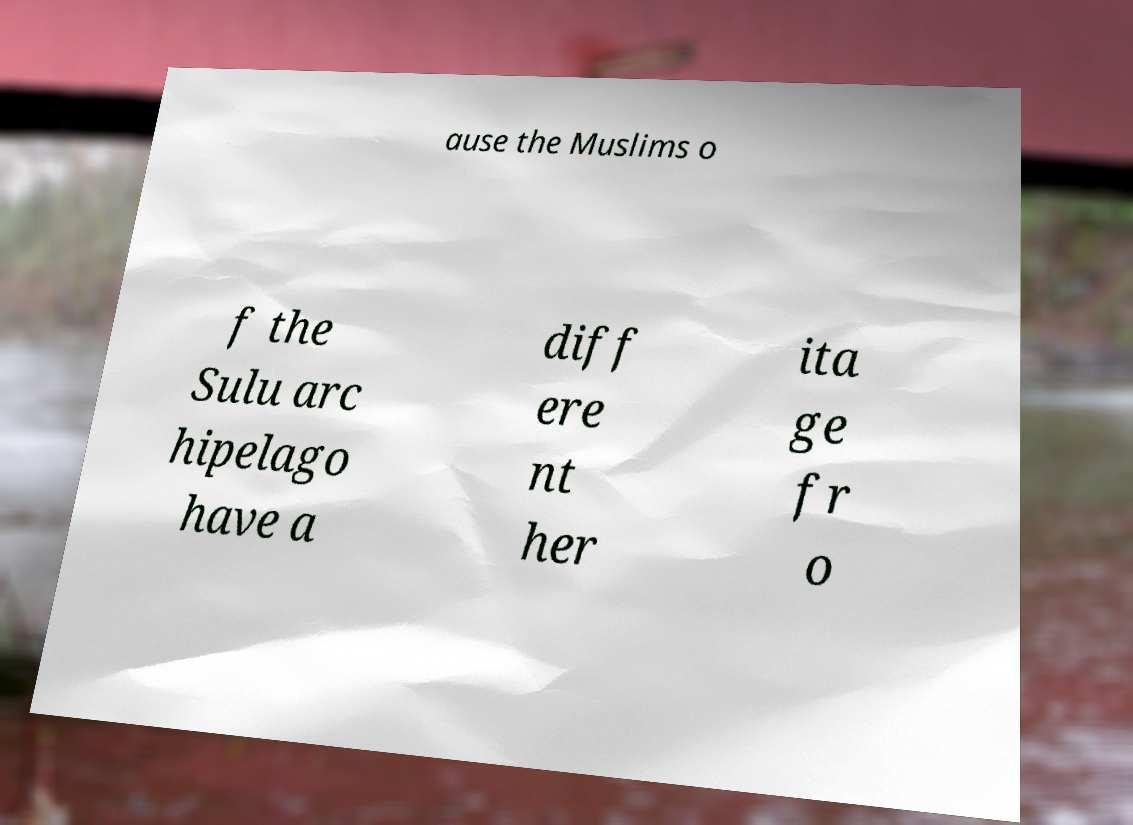Could you assist in decoding the text presented in this image and type it out clearly? ause the Muslims o f the Sulu arc hipelago have a diff ere nt her ita ge fr o 